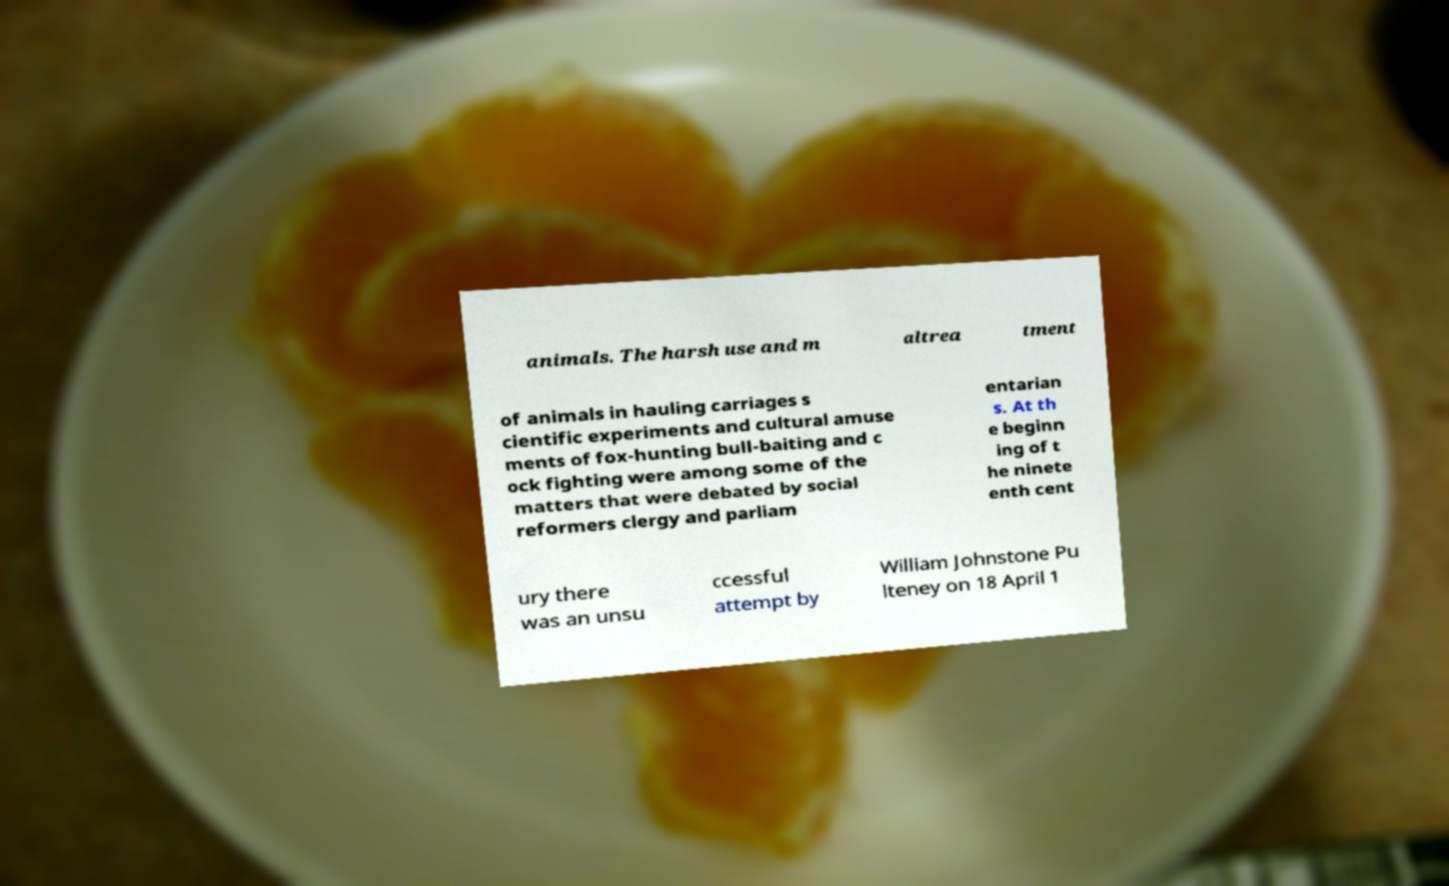There's text embedded in this image that I need extracted. Can you transcribe it verbatim? animals. The harsh use and m altrea tment of animals in hauling carriages s cientific experiments and cultural amuse ments of fox-hunting bull-baiting and c ock fighting were among some of the matters that were debated by social reformers clergy and parliam entarian s. At th e beginn ing of t he ninete enth cent ury there was an unsu ccessful attempt by William Johnstone Pu lteney on 18 April 1 